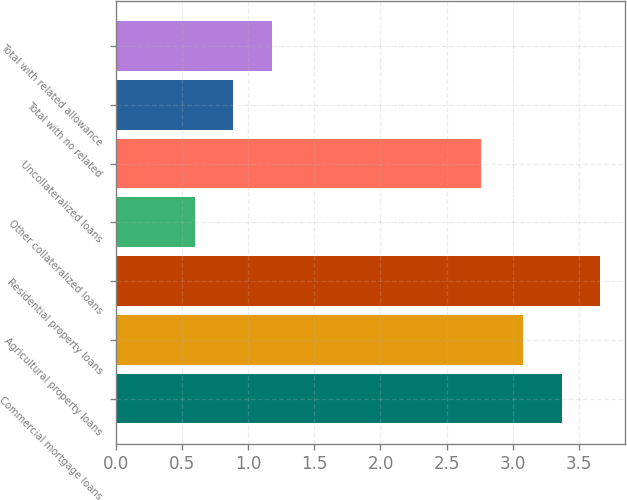Convert chart. <chart><loc_0><loc_0><loc_500><loc_500><bar_chart><fcel>Commercial mortgage loans<fcel>Agricultural property loans<fcel>Residential property loans<fcel>Other collateralized loans<fcel>Uncollateralized loans<fcel>Total with no related<fcel>Total with related allowance<nl><fcel>3.37<fcel>3.08<fcel>3.66<fcel>0.6<fcel>2.76<fcel>0.89<fcel>1.18<nl></chart> 